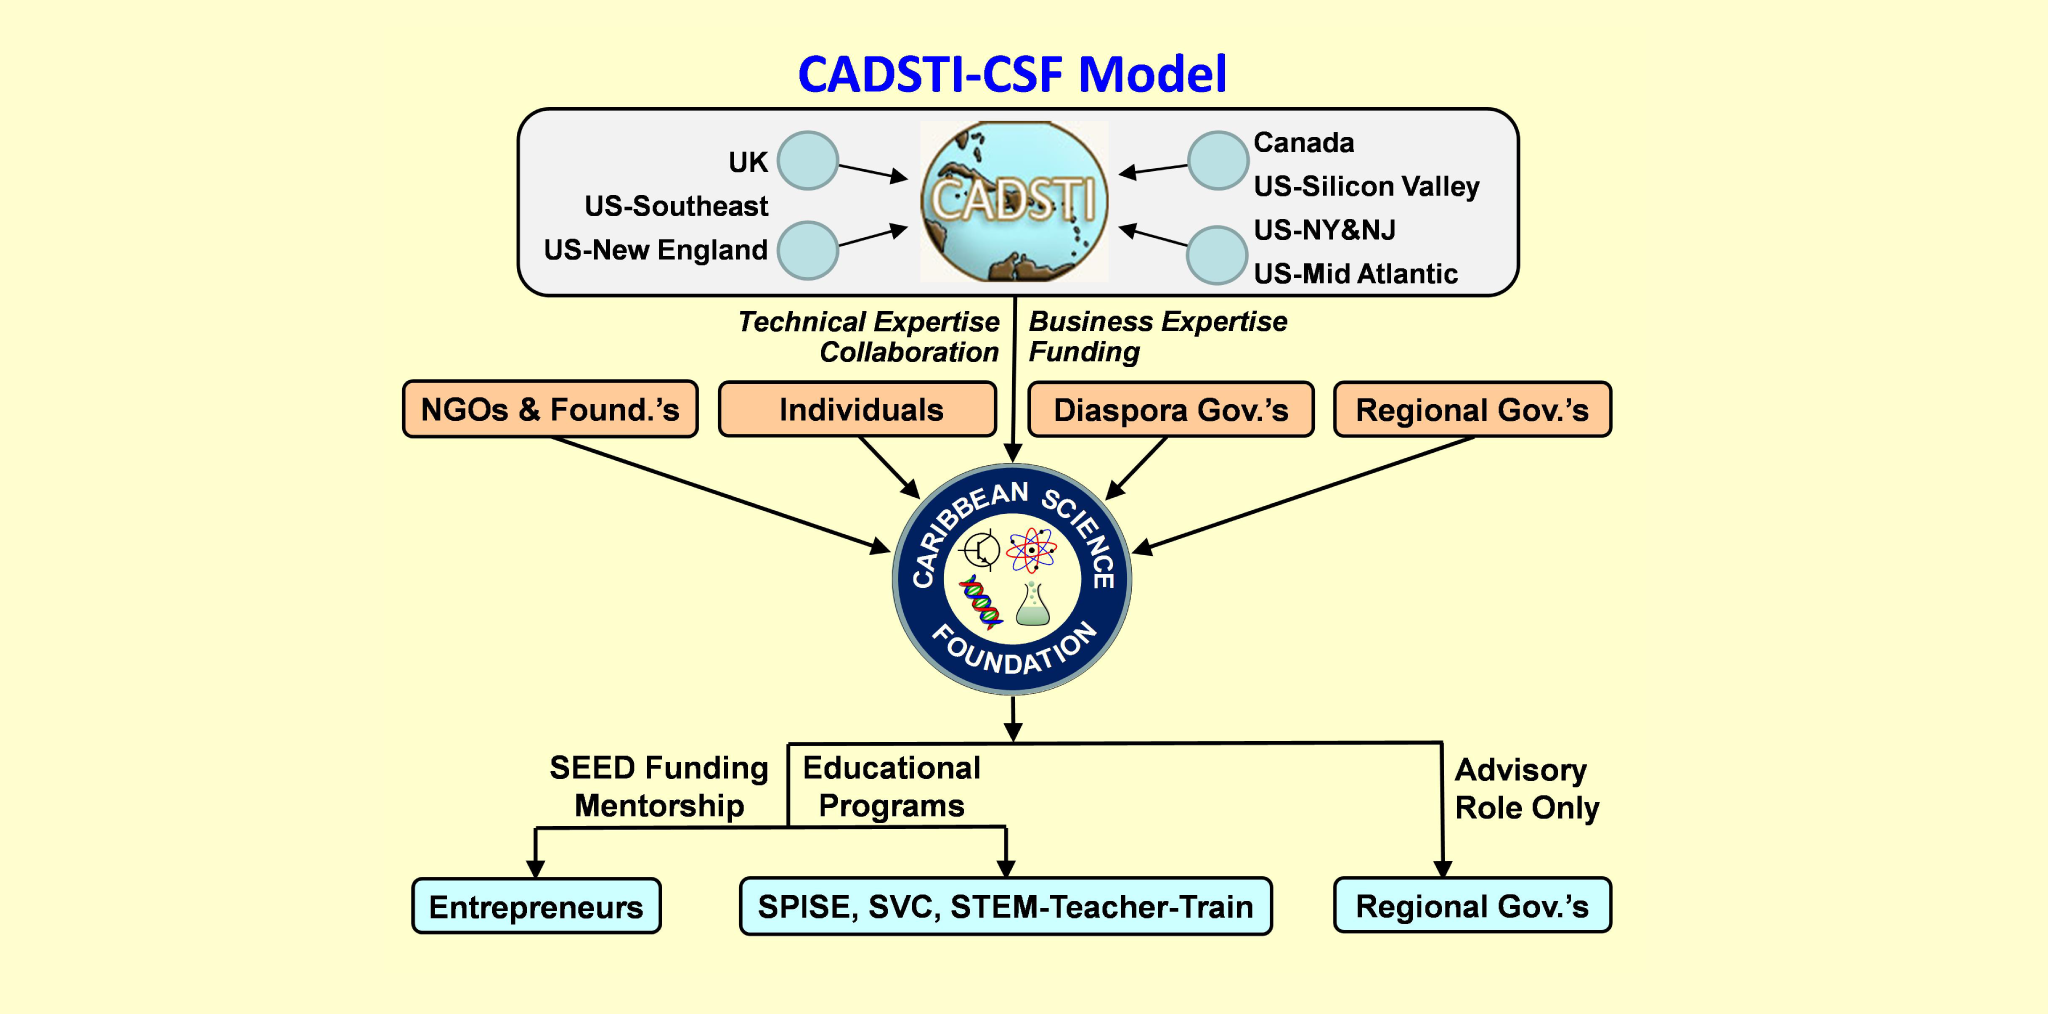Considering the various geographic locations listed in the flowchart, what could be the significance of the Caribbean Science Foundation's collaboration with these particular regions, and how might these partnerships benefit the foundation's mission? The collaboration between the Caribbean Science Foundation (CSF) and various regions such as the UK, Canada, and different parts of the United States signifies an extensive network of expertise and resources. By partnering with these regions, the CSF leverages technical expertise, business acumen, and funding opportunities. These partnerships aim to enhance educational programs and entrepreneurship in the Caribbean science sector. The engagement with diaspora and regional governments allows the CSF to tap into a global community's skills and networks, which is crucial for advancing science education, fostering innovation, and ultimately building robust scientific and entrepreneurial ecosystems in the Caribbean. 